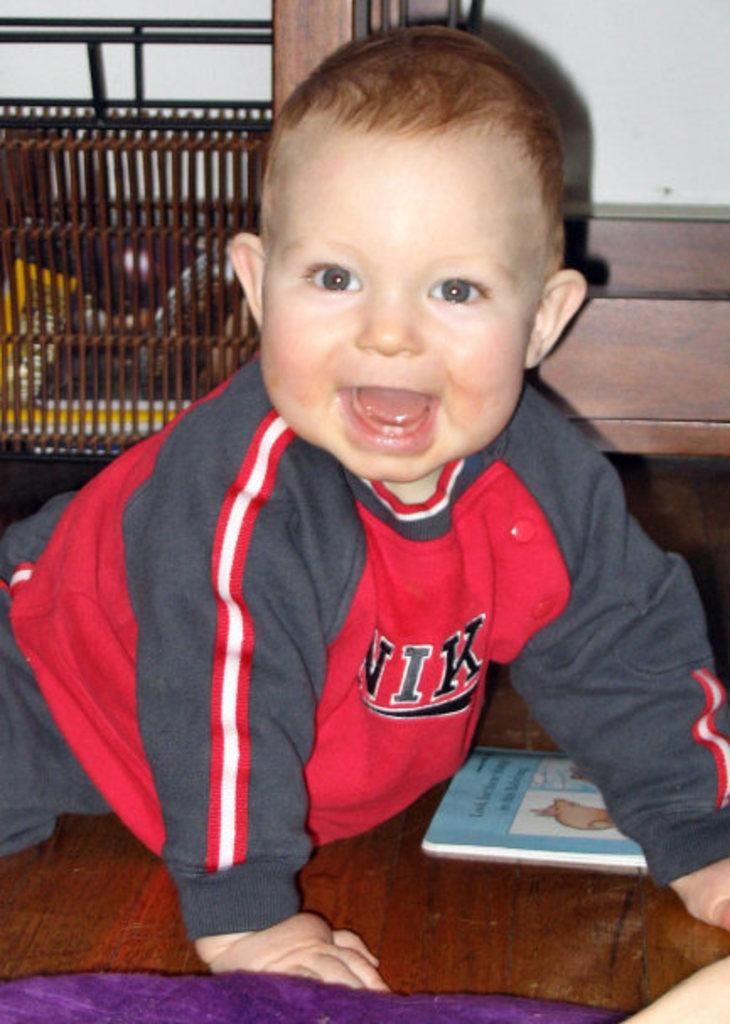Who is the main subject in the image? There is a boy in the image. What is the boy wearing? The boy is wearing a red t-shirt. What is the boy doing in the image? The boy is crawling on the wooden floor. What object is near the boy? There is a book beside the boy. What can be seen behind the boy? There is a wall behind the boy. What type of humor can be seen in the boy's facial expression in the image? There is no indication of humor or facial expression in the image, as it only shows the boy crawling on the wooden floor. 